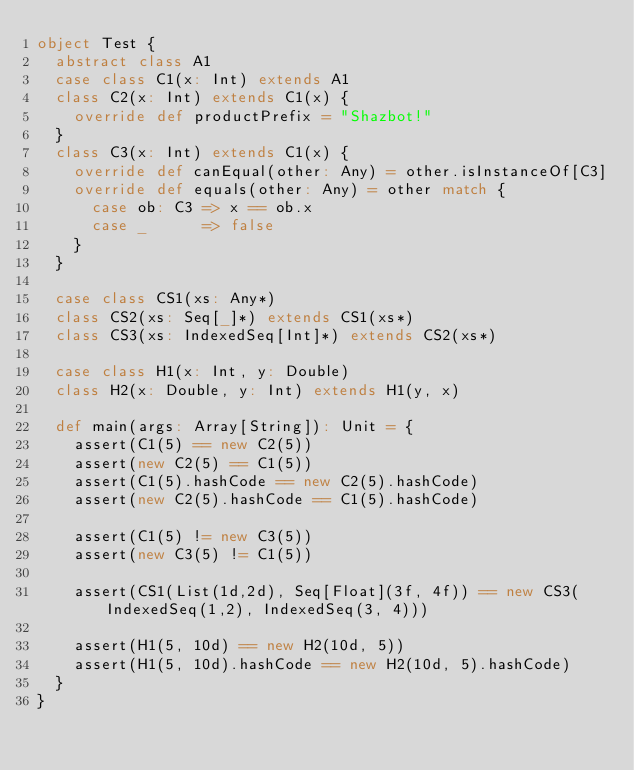<code> <loc_0><loc_0><loc_500><loc_500><_Scala_>object Test {
  abstract class A1
  case class C1(x: Int) extends A1
  class C2(x: Int) extends C1(x) {
    override def productPrefix = "Shazbot!"
  }
  class C3(x: Int) extends C1(x) {
    override def canEqual(other: Any) = other.isInstanceOf[C3]
    override def equals(other: Any) = other match {
      case ob: C3 => x == ob.x
      case _      => false
    }
  }

  case class CS1(xs: Any*)
  class CS2(xs: Seq[_]*) extends CS1(xs*)
  class CS3(xs: IndexedSeq[Int]*) extends CS2(xs*)

  case class H1(x: Int, y: Double)
  class H2(x: Double, y: Int) extends H1(y, x)

  def main(args: Array[String]): Unit = {
    assert(C1(5) == new C2(5))
    assert(new C2(5) == C1(5))
    assert(C1(5).hashCode == new C2(5).hashCode)
    assert(new C2(5).hashCode == C1(5).hashCode)

    assert(C1(5) != new C3(5))
    assert(new C3(5) != C1(5))

    assert(CS1(List(1d,2d), Seq[Float](3f, 4f)) == new CS3(IndexedSeq(1,2), IndexedSeq(3, 4)))

    assert(H1(5, 10d) == new H2(10d, 5))
    assert(H1(5, 10d).hashCode == new H2(10d, 5).hashCode)
  }
}
</code> 